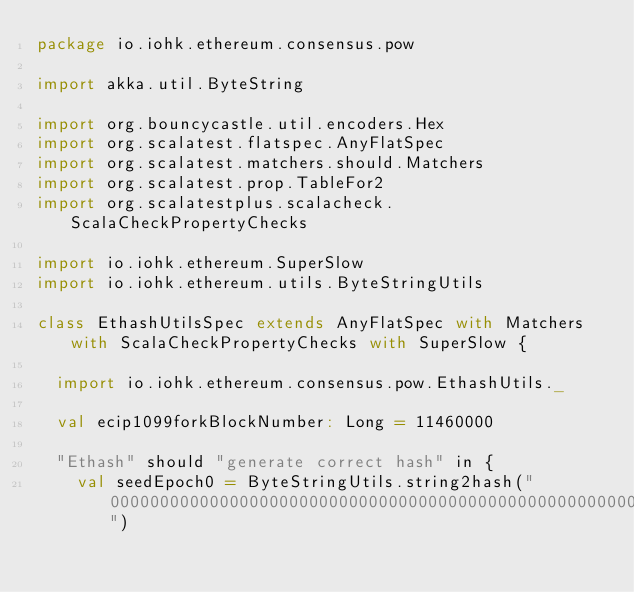Convert code to text. <code><loc_0><loc_0><loc_500><loc_500><_Scala_>package io.iohk.ethereum.consensus.pow

import akka.util.ByteString

import org.bouncycastle.util.encoders.Hex
import org.scalatest.flatspec.AnyFlatSpec
import org.scalatest.matchers.should.Matchers
import org.scalatest.prop.TableFor2
import org.scalatestplus.scalacheck.ScalaCheckPropertyChecks

import io.iohk.ethereum.SuperSlow
import io.iohk.ethereum.utils.ByteStringUtils

class EthashUtilsSpec extends AnyFlatSpec with Matchers with ScalaCheckPropertyChecks with SuperSlow {

  import io.iohk.ethereum.consensus.pow.EthashUtils._

  val ecip1099forkBlockNumber: Long = 11460000

  "Ethash" should "generate correct hash" in {
    val seedEpoch0 = ByteStringUtils.string2hash("0000000000000000000000000000000000000000000000000000000000000000")</code> 